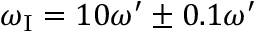<formula> <loc_0><loc_0><loc_500><loc_500>\omega _ { I } = 1 0 \omega ^ { \prime } \pm 0 . 1 \omega ^ { \prime }</formula> 